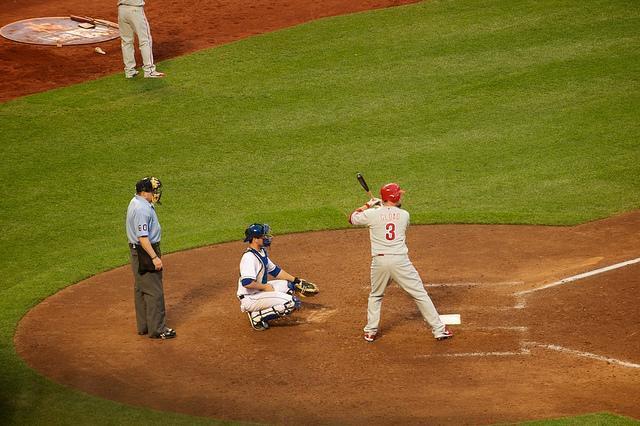How many people can be seen?
Give a very brief answer. 4. 